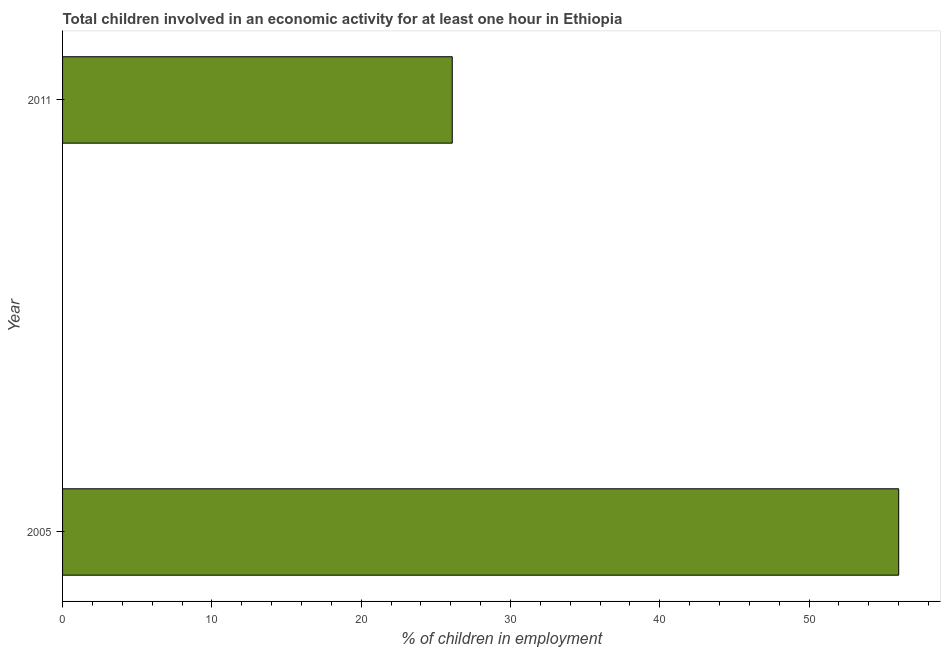What is the title of the graph?
Ensure brevity in your answer.  Total children involved in an economic activity for at least one hour in Ethiopia. What is the label or title of the X-axis?
Offer a very short reply. % of children in employment. What is the percentage of children in employment in 2011?
Ensure brevity in your answer.  26.1. Across all years, what is the maximum percentage of children in employment?
Your response must be concise. 56. Across all years, what is the minimum percentage of children in employment?
Give a very brief answer. 26.1. What is the sum of the percentage of children in employment?
Ensure brevity in your answer.  82.1. What is the difference between the percentage of children in employment in 2005 and 2011?
Your answer should be very brief. 29.9. What is the average percentage of children in employment per year?
Offer a very short reply. 41.05. What is the median percentage of children in employment?
Provide a short and direct response. 41.05. Do a majority of the years between 2011 and 2005 (inclusive) have percentage of children in employment greater than 48 %?
Provide a short and direct response. No. What is the ratio of the percentage of children in employment in 2005 to that in 2011?
Your answer should be compact. 2.15. Is the percentage of children in employment in 2005 less than that in 2011?
Offer a terse response. No. In how many years, is the percentage of children in employment greater than the average percentage of children in employment taken over all years?
Your answer should be very brief. 1. How many years are there in the graph?
Your answer should be very brief. 2. What is the difference between two consecutive major ticks on the X-axis?
Ensure brevity in your answer.  10. Are the values on the major ticks of X-axis written in scientific E-notation?
Make the answer very short. No. What is the % of children in employment in 2005?
Ensure brevity in your answer.  56. What is the % of children in employment of 2011?
Make the answer very short. 26.1. What is the difference between the % of children in employment in 2005 and 2011?
Offer a terse response. 29.9. What is the ratio of the % of children in employment in 2005 to that in 2011?
Ensure brevity in your answer.  2.15. 